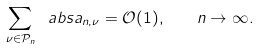<formula> <loc_0><loc_0><loc_500><loc_500>\sum _ { \nu \in \mathcal { P } _ { n } } \ a b s { a _ { n , \nu } } = \mathcal { O } ( 1 ) , \quad n \rightarrow \infty .</formula> 